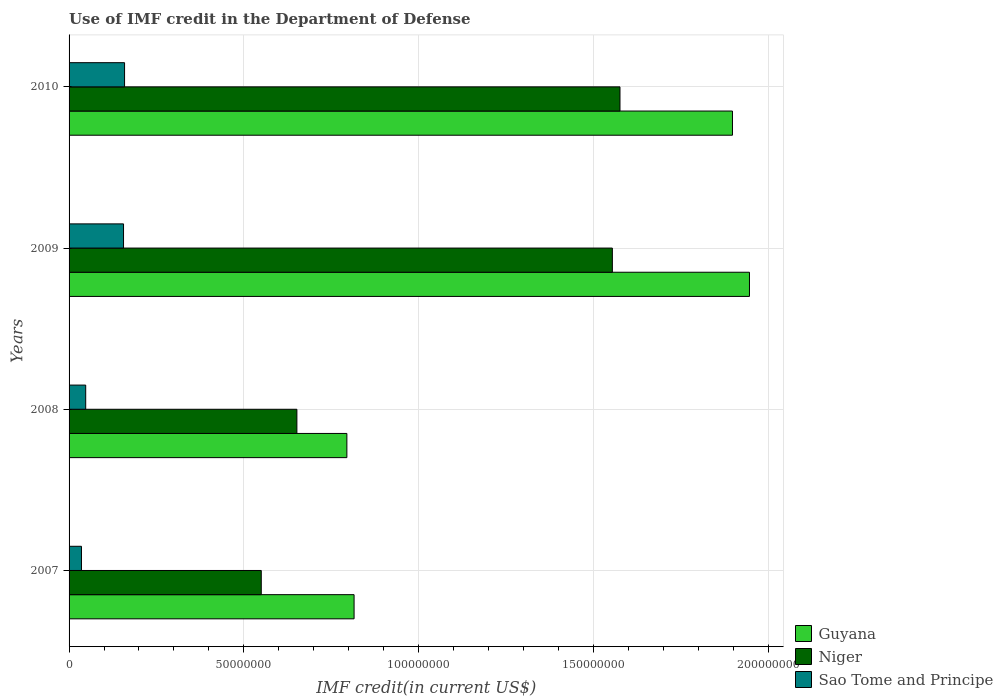How many different coloured bars are there?
Provide a short and direct response. 3. Are the number of bars per tick equal to the number of legend labels?
Make the answer very short. Yes. How many bars are there on the 3rd tick from the top?
Your response must be concise. 3. What is the label of the 3rd group of bars from the top?
Provide a succinct answer. 2008. In how many cases, is the number of bars for a given year not equal to the number of legend labels?
Your answer should be compact. 0. What is the IMF credit in the Department of Defense in Niger in 2008?
Offer a terse response. 6.52e+07. Across all years, what is the maximum IMF credit in the Department of Defense in Guyana?
Provide a short and direct response. 1.95e+08. Across all years, what is the minimum IMF credit in the Department of Defense in Sao Tome and Principe?
Provide a short and direct response. 3.55e+06. In which year was the IMF credit in the Department of Defense in Niger maximum?
Offer a terse response. 2010. In which year was the IMF credit in the Department of Defense in Guyana minimum?
Provide a succinct answer. 2008. What is the total IMF credit in the Department of Defense in Guyana in the graph?
Give a very brief answer. 5.45e+08. What is the difference between the IMF credit in the Department of Defense in Sao Tome and Principe in 2008 and that in 2010?
Keep it short and to the point. -1.11e+07. What is the difference between the IMF credit in the Department of Defense in Niger in 2009 and the IMF credit in the Department of Defense in Guyana in 2008?
Your response must be concise. 7.59e+07. What is the average IMF credit in the Department of Defense in Niger per year?
Make the answer very short. 1.08e+08. In the year 2009, what is the difference between the IMF credit in the Department of Defense in Sao Tome and Principe and IMF credit in the Department of Defense in Guyana?
Your response must be concise. -1.79e+08. In how many years, is the IMF credit in the Department of Defense in Guyana greater than 20000000 US$?
Offer a terse response. 4. What is the ratio of the IMF credit in the Department of Defense in Sao Tome and Principe in 2007 to that in 2008?
Make the answer very short. 0.75. What is the difference between the highest and the second highest IMF credit in the Department of Defense in Guyana?
Keep it short and to the point. 4.86e+06. What is the difference between the highest and the lowest IMF credit in the Department of Defense in Guyana?
Your answer should be compact. 1.15e+08. In how many years, is the IMF credit in the Department of Defense in Sao Tome and Principe greater than the average IMF credit in the Department of Defense in Sao Tome and Principe taken over all years?
Ensure brevity in your answer.  2. What does the 2nd bar from the top in 2009 represents?
Ensure brevity in your answer.  Niger. What does the 2nd bar from the bottom in 2010 represents?
Your response must be concise. Niger. Is it the case that in every year, the sum of the IMF credit in the Department of Defense in Niger and IMF credit in the Department of Defense in Guyana is greater than the IMF credit in the Department of Defense in Sao Tome and Principe?
Give a very brief answer. Yes. Are all the bars in the graph horizontal?
Give a very brief answer. Yes. How many years are there in the graph?
Your answer should be very brief. 4. Does the graph contain any zero values?
Ensure brevity in your answer.  No. Where does the legend appear in the graph?
Keep it short and to the point. Bottom right. How many legend labels are there?
Provide a succinct answer. 3. What is the title of the graph?
Offer a very short reply. Use of IMF credit in the Department of Defense. Does "Angola" appear as one of the legend labels in the graph?
Make the answer very short. No. What is the label or title of the X-axis?
Keep it short and to the point. IMF credit(in current US$). What is the label or title of the Y-axis?
Your response must be concise. Years. What is the IMF credit(in current US$) of Guyana in 2007?
Your answer should be compact. 8.15e+07. What is the IMF credit(in current US$) in Niger in 2007?
Give a very brief answer. 5.50e+07. What is the IMF credit(in current US$) of Sao Tome and Principe in 2007?
Your answer should be very brief. 3.55e+06. What is the IMF credit(in current US$) in Guyana in 2008?
Your answer should be very brief. 7.95e+07. What is the IMF credit(in current US$) in Niger in 2008?
Make the answer very short. 6.52e+07. What is the IMF credit(in current US$) in Sao Tome and Principe in 2008?
Ensure brevity in your answer.  4.76e+06. What is the IMF credit(in current US$) of Guyana in 2009?
Keep it short and to the point. 1.95e+08. What is the IMF credit(in current US$) of Niger in 2009?
Offer a very short reply. 1.55e+08. What is the IMF credit(in current US$) of Sao Tome and Principe in 2009?
Give a very brief answer. 1.56e+07. What is the IMF credit(in current US$) in Guyana in 2010?
Provide a succinct answer. 1.90e+08. What is the IMF credit(in current US$) of Niger in 2010?
Provide a succinct answer. 1.58e+08. What is the IMF credit(in current US$) of Sao Tome and Principe in 2010?
Provide a short and direct response. 1.59e+07. Across all years, what is the maximum IMF credit(in current US$) in Guyana?
Offer a very short reply. 1.95e+08. Across all years, what is the maximum IMF credit(in current US$) in Niger?
Your response must be concise. 1.58e+08. Across all years, what is the maximum IMF credit(in current US$) of Sao Tome and Principe?
Your answer should be very brief. 1.59e+07. Across all years, what is the minimum IMF credit(in current US$) of Guyana?
Your answer should be very brief. 7.95e+07. Across all years, what is the minimum IMF credit(in current US$) in Niger?
Your response must be concise. 5.50e+07. Across all years, what is the minimum IMF credit(in current US$) of Sao Tome and Principe?
Your answer should be very brief. 3.55e+06. What is the total IMF credit(in current US$) of Guyana in the graph?
Your response must be concise. 5.45e+08. What is the total IMF credit(in current US$) in Niger in the graph?
Make the answer very short. 4.33e+08. What is the total IMF credit(in current US$) of Sao Tome and Principe in the graph?
Give a very brief answer. 3.98e+07. What is the difference between the IMF credit(in current US$) in Guyana in 2007 and that in 2008?
Keep it short and to the point. 2.06e+06. What is the difference between the IMF credit(in current US$) in Niger in 2007 and that in 2008?
Give a very brief answer. -1.02e+07. What is the difference between the IMF credit(in current US$) in Sao Tome and Principe in 2007 and that in 2008?
Your answer should be compact. -1.21e+06. What is the difference between the IMF credit(in current US$) in Guyana in 2007 and that in 2009?
Make the answer very short. -1.13e+08. What is the difference between the IMF credit(in current US$) in Niger in 2007 and that in 2009?
Provide a short and direct response. -1.00e+08. What is the difference between the IMF credit(in current US$) in Sao Tome and Principe in 2007 and that in 2009?
Make the answer very short. -1.20e+07. What is the difference between the IMF credit(in current US$) of Guyana in 2007 and that in 2010?
Your answer should be very brief. -1.08e+08. What is the difference between the IMF credit(in current US$) of Niger in 2007 and that in 2010?
Keep it short and to the point. -1.03e+08. What is the difference between the IMF credit(in current US$) in Sao Tome and Principe in 2007 and that in 2010?
Give a very brief answer. -1.23e+07. What is the difference between the IMF credit(in current US$) in Guyana in 2008 and that in 2009?
Keep it short and to the point. -1.15e+08. What is the difference between the IMF credit(in current US$) of Niger in 2008 and that in 2009?
Give a very brief answer. -9.02e+07. What is the difference between the IMF credit(in current US$) of Sao Tome and Principe in 2008 and that in 2009?
Your answer should be compact. -1.08e+07. What is the difference between the IMF credit(in current US$) of Guyana in 2008 and that in 2010?
Make the answer very short. -1.10e+08. What is the difference between the IMF credit(in current US$) in Niger in 2008 and that in 2010?
Provide a succinct answer. -9.24e+07. What is the difference between the IMF credit(in current US$) of Sao Tome and Principe in 2008 and that in 2010?
Provide a succinct answer. -1.11e+07. What is the difference between the IMF credit(in current US$) of Guyana in 2009 and that in 2010?
Ensure brevity in your answer.  4.86e+06. What is the difference between the IMF credit(in current US$) in Niger in 2009 and that in 2010?
Your answer should be compact. -2.18e+06. What is the difference between the IMF credit(in current US$) of Sao Tome and Principe in 2009 and that in 2010?
Your answer should be compact. -2.94e+05. What is the difference between the IMF credit(in current US$) of Guyana in 2007 and the IMF credit(in current US$) of Niger in 2008?
Offer a terse response. 1.64e+07. What is the difference between the IMF credit(in current US$) in Guyana in 2007 and the IMF credit(in current US$) in Sao Tome and Principe in 2008?
Provide a succinct answer. 7.68e+07. What is the difference between the IMF credit(in current US$) of Niger in 2007 and the IMF credit(in current US$) of Sao Tome and Principe in 2008?
Provide a succinct answer. 5.02e+07. What is the difference between the IMF credit(in current US$) of Guyana in 2007 and the IMF credit(in current US$) of Niger in 2009?
Give a very brief answer. -7.39e+07. What is the difference between the IMF credit(in current US$) of Guyana in 2007 and the IMF credit(in current US$) of Sao Tome and Principe in 2009?
Offer a terse response. 6.59e+07. What is the difference between the IMF credit(in current US$) of Niger in 2007 and the IMF credit(in current US$) of Sao Tome and Principe in 2009?
Keep it short and to the point. 3.94e+07. What is the difference between the IMF credit(in current US$) of Guyana in 2007 and the IMF credit(in current US$) of Niger in 2010?
Offer a very short reply. -7.61e+07. What is the difference between the IMF credit(in current US$) in Guyana in 2007 and the IMF credit(in current US$) in Sao Tome and Principe in 2010?
Offer a very short reply. 6.57e+07. What is the difference between the IMF credit(in current US$) in Niger in 2007 and the IMF credit(in current US$) in Sao Tome and Principe in 2010?
Offer a very short reply. 3.91e+07. What is the difference between the IMF credit(in current US$) in Guyana in 2008 and the IMF credit(in current US$) in Niger in 2009?
Offer a terse response. -7.59e+07. What is the difference between the IMF credit(in current US$) of Guyana in 2008 and the IMF credit(in current US$) of Sao Tome and Principe in 2009?
Your answer should be very brief. 6.39e+07. What is the difference between the IMF credit(in current US$) in Niger in 2008 and the IMF credit(in current US$) in Sao Tome and Principe in 2009?
Make the answer very short. 4.96e+07. What is the difference between the IMF credit(in current US$) of Guyana in 2008 and the IMF credit(in current US$) of Niger in 2010?
Offer a very short reply. -7.81e+07. What is the difference between the IMF credit(in current US$) of Guyana in 2008 and the IMF credit(in current US$) of Sao Tome and Principe in 2010?
Your answer should be compact. 6.36e+07. What is the difference between the IMF credit(in current US$) of Niger in 2008 and the IMF credit(in current US$) of Sao Tome and Principe in 2010?
Provide a short and direct response. 4.93e+07. What is the difference between the IMF credit(in current US$) in Guyana in 2009 and the IMF credit(in current US$) in Niger in 2010?
Your answer should be compact. 3.70e+07. What is the difference between the IMF credit(in current US$) in Guyana in 2009 and the IMF credit(in current US$) in Sao Tome and Principe in 2010?
Make the answer very short. 1.79e+08. What is the difference between the IMF credit(in current US$) of Niger in 2009 and the IMF credit(in current US$) of Sao Tome and Principe in 2010?
Your answer should be very brief. 1.40e+08. What is the average IMF credit(in current US$) of Guyana per year?
Ensure brevity in your answer.  1.36e+08. What is the average IMF credit(in current US$) in Niger per year?
Give a very brief answer. 1.08e+08. What is the average IMF credit(in current US$) of Sao Tome and Principe per year?
Your answer should be compact. 9.94e+06. In the year 2007, what is the difference between the IMF credit(in current US$) in Guyana and IMF credit(in current US$) in Niger?
Provide a short and direct response. 2.65e+07. In the year 2007, what is the difference between the IMF credit(in current US$) of Guyana and IMF credit(in current US$) of Sao Tome and Principe?
Provide a short and direct response. 7.80e+07. In the year 2007, what is the difference between the IMF credit(in current US$) of Niger and IMF credit(in current US$) of Sao Tome and Principe?
Ensure brevity in your answer.  5.14e+07. In the year 2008, what is the difference between the IMF credit(in current US$) of Guyana and IMF credit(in current US$) of Niger?
Ensure brevity in your answer.  1.43e+07. In the year 2008, what is the difference between the IMF credit(in current US$) of Guyana and IMF credit(in current US$) of Sao Tome and Principe?
Provide a short and direct response. 7.47e+07. In the year 2008, what is the difference between the IMF credit(in current US$) in Niger and IMF credit(in current US$) in Sao Tome and Principe?
Keep it short and to the point. 6.04e+07. In the year 2009, what is the difference between the IMF credit(in current US$) of Guyana and IMF credit(in current US$) of Niger?
Offer a very short reply. 3.92e+07. In the year 2009, what is the difference between the IMF credit(in current US$) in Guyana and IMF credit(in current US$) in Sao Tome and Principe?
Provide a succinct answer. 1.79e+08. In the year 2009, what is the difference between the IMF credit(in current US$) in Niger and IMF credit(in current US$) in Sao Tome and Principe?
Your answer should be compact. 1.40e+08. In the year 2010, what is the difference between the IMF credit(in current US$) in Guyana and IMF credit(in current US$) in Niger?
Provide a succinct answer. 3.22e+07. In the year 2010, what is the difference between the IMF credit(in current US$) in Guyana and IMF credit(in current US$) in Sao Tome and Principe?
Offer a terse response. 1.74e+08. In the year 2010, what is the difference between the IMF credit(in current US$) in Niger and IMF credit(in current US$) in Sao Tome and Principe?
Provide a succinct answer. 1.42e+08. What is the ratio of the IMF credit(in current US$) of Guyana in 2007 to that in 2008?
Your answer should be very brief. 1.03. What is the ratio of the IMF credit(in current US$) of Niger in 2007 to that in 2008?
Make the answer very short. 0.84. What is the ratio of the IMF credit(in current US$) in Sao Tome and Principe in 2007 to that in 2008?
Your response must be concise. 0.75. What is the ratio of the IMF credit(in current US$) in Guyana in 2007 to that in 2009?
Provide a succinct answer. 0.42. What is the ratio of the IMF credit(in current US$) in Niger in 2007 to that in 2009?
Make the answer very short. 0.35. What is the ratio of the IMF credit(in current US$) in Sao Tome and Principe in 2007 to that in 2009?
Offer a terse response. 0.23. What is the ratio of the IMF credit(in current US$) of Guyana in 2007 to that in 2010?
Provide a succinct answer. 0.43. What is the ratio of the IMF credit(in current US$) of Niger in 2007 to that in 2010?
Offer a very short reply. 0.35. What is the ratio of the IMF credit(in current US$) of Sao Tome and Principe in 2007 to that in 2010?
Provide a succinct answer. 0.22. What is the ratio of the IMF credit(in current US$) in Guyana in 2008 to that in 2009?
Offer a terse response. 0.41. What is the ratio of the IMF credit(in current US$) of Niger in 2008 to that in 2009?
Your answer should be compact. 0.42. What is the ratio of the IMF credit(in current US$) of Sao Tome and Principe in 2008 to that in 2009?
Your answer should be compact. 0.31. What is the ratio of the IMF credit(in current US$) in Guyana in 2008 to that in 2010?
Your response must be concise. 0.42. What is the ratio of the IMF credit(in current US$) of Niger in 2008 to that in 2010?
Give a very brief answer. 0.41. What is the ratio of the IMF credit(in current US$) in Sao Tome and Principe in 2008 to that in 2010?
Your response must be concise. 0.3. What is the ratio of the IMF credit(in current US$) of Guyana in 2009 to that in 2010?
Give a very brief answer. 1.03. What is the ratio of the IMF credit(in current US$) in Niger in 2009 to that in 2010?
Provide a short and direct response. 0.99. What is the ratio of the IMF credit(in current US$) in Sao Tome and Principe in 2009 to that in 2010?
Keep it short and to the point. 0.98. What is the difference between the highest and the second highest IMF credit(in current US$) in Guyana?
Keep it short and to the point. 4.86e+06. What is the difference between the highest and the second highest IMF credit(in current US$) of Niger?
Your answer should be very brief. 2.18e+06. What is the difference between the highest and the second highest IMF credit(in current US$) of Sao Tome and Principe?
Your response must be concise. 2.94e+05. What is the difference between the highest and the lowest IMF credit(in current US$) of Guyana?
Your response must be concise. 1.15e+08. What is the difference between the highest and the lowest IMF credit(in current US$) in Niger?
Provide a short and direct response. 1.03e+08. What is the difference between the highest and the lowest IMF credit(in current US$) of Sao Tome and Principe?
Your answer should be compact. 1.23e+07. 